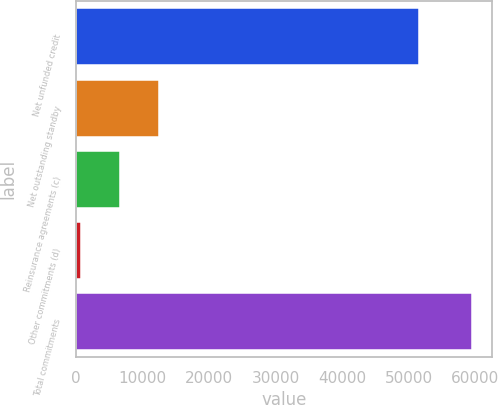<chart> <loc_0><loc_0><loc_500><loc_500><bar_chart><fcel>Net unfunded credit<fcel>Net outstanding standby<fcel>Reinsurance agreements (c)<fcel>Other commitments (d)<fcel>Total commitments<nl><fcel>51581<fcel>12512.6<fcel>6637.8<fcel>763<fcel>59511<nl></chart> 